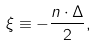Convert formula to latex. <formula><loc_0><loc_0><loc_500><loc_500>\xi \equiv - \frac { n \cdot \Delta } { 2 } ,</formula> 